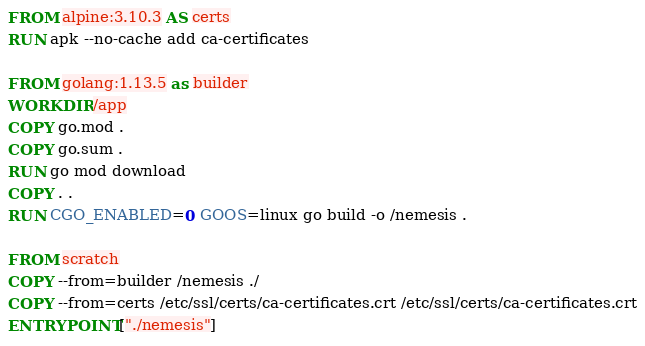Convert code to text. <code><loc_0><loc_0><loc_500><loc_500><_Dockerfile_>FROM alpine:3.10.3 AS certs
RUN apk --no-cache add ca-certificates

FROM golang:1.13.5 as builder
WORKDIR /app
COPY go.mod .
COPY go.sum .
RUN go mod download
COPY . .
RUN CGO_ENABLED=0 GOOS=linux go build -o /nemesis .

FROM scratch
COPY --from=builder /nemesis ./
COPY --from=certs /etc/ssl/certs/ca-certificates.crt /etc/ssl/certs/ca-certificates.crt
ENTRYPOINT ["./nemesis"]</code> 